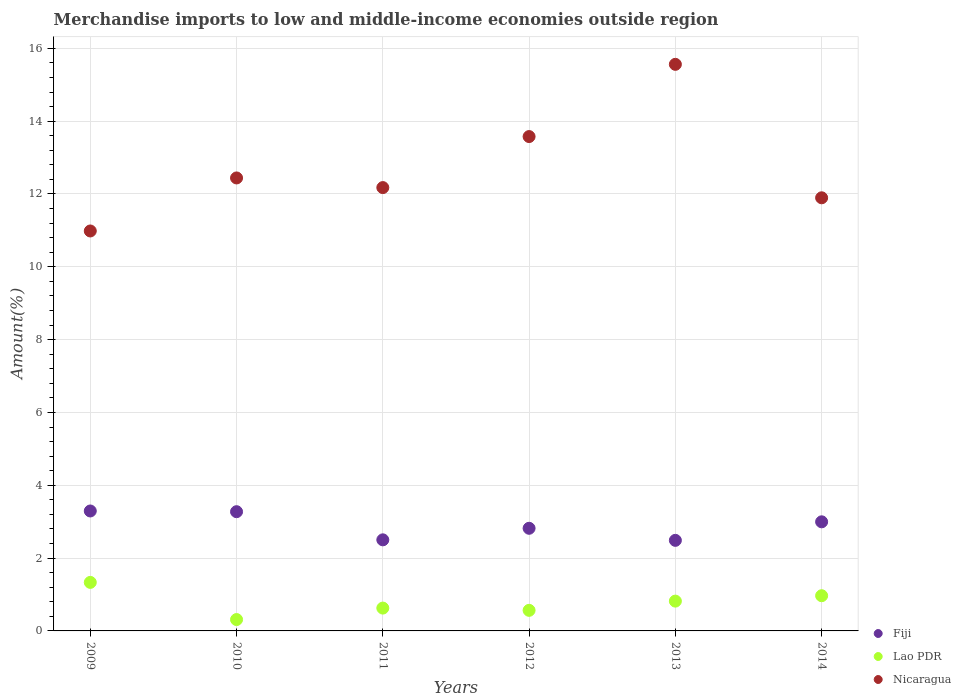How many different coloured dotlines are there?
Ensure brevity in your answer.  3. What is the percentage of amount earned from merchandise imports in Nicaragua in 2012?
Provide a short and direct response. 13.58. Across all years, what is the maximum percentage of amount earned from merchandise imports in Fiji?
Your answer should be very brief. 3.29. Across all years, what is the minimum percentage of amount earned from merchandise imports in Lao PDR?
Provide a succinct answer. 0.31. In which year was the percentage of amount earned from merchandise imports in Lao PDR minimum?
Your answer should be very brief. 2010. What is the total percentage of amount earned from merchandise imports in Lao PDR in the graph?
Provide a short and direct response. 4.62. What is the difference between the percentage of amount earned from merchandise imports in Fiji in 2010 and that in 2011?
Give a very brief answer. 0.77. What is the difference between the percentage of amount earned from merchandise imports in Nicaragua in 2011 and the percentage of amount earned from merchandise imports in Fiji in 2010?
Provide a succinct answer. 8.9. What is the average percentage of amount earned from merchandise imports in Nicaragua per year?
Provide a short and direct response. 12.77. In the year 2009, what is the difference between the percentage of amount earned from merchandise imports in Fiji and percentage of amount earned from merchandise imports in Lao PDR?
Your answer should be very brief. 1.96. In how many years, is the percentage of amount earned from merchandise imports in Lao PDR greater than 13.6 %?
Ensure brevity in your answer.  0. What is the ratio of the percentage of amount earned from merchandise imports in Fiji in 2009 to that in 2011?
Your answer should be very brief. 1.32. Is the percentage of amount earned from merchandise imports in Lao PDR in 2012 less than that in 2013?
Make the answer very short. Yes. What is the difference between the highest and the second highest percentage of amount earned from merchandise imports in Nicaragua?
Your answer should be very brief. 1.98. What is the difference between the highest and the lowest percentage of amount earned from merchandise imports in Lao PDR?
Keep it short and to the point. 1.02. Is it the case that in every year, the sum of the percentage of amount earned from merchandise imports in Nicaragua and percentage of amount earned from merchandise imports in Lao PDR  is greater than the percentage of amount earned from merchandise imports in Fiji?
Your answer should be compact. Yes. Does the percentage of amount earned from merchandise imports in Fiji monotonically increase over the years?
Your answer should be compact. No. Is the percentage of amount earned from merchandise imports in Nicaragua strictly greater than the percentage of amount earned from merchandise imports in Lao PDR over the years?
Provide a short and direct response. Yes. How many dotlines are there?
Provide a succinct answer. 3. How many years are there in the graph?
Keep it short and to the point. 6. What is the difference between two consecutive major ticks on the Y-axis?
Make the answer very short. 2. How are the legend labels stacked?
Provide a succinct answer. Vertical. What is the title of the graph?
Offer a very short reply. Merchandise imports to low and middle-income economies outside region. What is the label or title of the Y-axis?
Make the answer very short. Amount(%). What is the Amount(%) in Fiji in 2009?
Provide a succinct answer. 3.29. What is the Amount(%) of Lao PDR in 2009?
Your answer should be very brief. 1.33. What is the Amount(%) in Nicaragua in 2009?
Give a very brief answer. 10.98. What is the Amount(%) in Fiji in 2010?
Make the answer very short. 3.27. What is the Amount(%) in Lao PDR in 2010?
Provide a short and direct response. 0.31. What is the Amount(%) of Nicaragua in 2010?
Provide a short and direct response. 12.44. What is the Amount(%) in Fiji in 2011?
Make the answer very short. 2.5. What is the Amount(%) of Lao PDR in 2011?
Make the answer very short. 0.63. What is the Amount(%) in Nicaragua in 2011?
Make the answer very short. 12.18. What is the Amount(%) in Fiji in 2012?
Keep it short and to the point. 2.82. What is the Amount(%) in Lao PDR in 2012?
Your answer should be compact. 0.57. What is the Amount(%) in Nicaragua in 2012?
Provide a short and direct response. 13.58. What is the Amount(%) of Fiji in 2013?
Your response must be concise. 2.49. What is the Amount(%) of Lao PDR in 2013?
Your answer should be very brief. 0.82. What is the Amount(%) in Nicaragua in 2013?
Make the answer very short. 15.56. What is the Amount(%) in Fiji in 2014?
Offer a terse response. 3. What is the Amount(%) in Lao PDR in 2014?
Keep it short and to the point. 0.97. What is the Amount(%) of Nicaragua in 2014?
Ensure brevity in your answer.  11.9. Across all years, what is the maximum Amount(%) in Fiji?
Your answer should be very brief. 3.29. Across all years, what is the maximum Amount(%) of Lao PDR?
Ensure brevity in your answer.  1.33. Across all years, what is the maximum Amount(%) in Nicaragua?
Offer a very short reply. 15.56. Across all years, what is the minimum Amount(%) of Fiji?
Provide a succinct answer. 2.49. Across all years, what is the minimum Amount(%) in Lao PDR?
Keep it short and to the point. 0.31. Across all years, what is the minimum Amount(%) of Nicaragua?
Offer a very short reply. 10.98. What is the total Amount(%) of Fiji in the graph?
Provide a short and direct response. 17.37. What is the total Amount(%) in Lao PDR in the graph?
Your response must be concise. 4.62. What is the total Amount(%) in Nicaragua in the graph?
Offer a terse response. 76.64. What is the difference between the Amount(%) in Fiji in 2009 and that in 2010?
Your response must be concise. 0.02. What is the difference between the Amount(%) in Lao PDR in 2009 and that in 2010?
Provide a short and direct response. 1.02. What is the difference between the Amount(%) of Nicaragua in 2009 and that in 2010?
Ensure brevity in your answer.  -1.46. What is the difference between the Amount(%) of Fiji in 2009 and that in 2011?
Give a very brief answer. 0.79. What is the difference between the Amount(%) of Lao PDR in 2009 and that in 2011?
Offer a very short reply. 0.71. What is the difference between the Amount(%) in Nicaragua in 2009 and that in 2011?
Provide a succinct answer. -1.19. What is the difference between the Amount(%) in Fiji in 2009 and that in 2012?
Your response must be concise. 0.48. What is the difference between the Amount(%) of Lao PDR in 2009 and that in 2012?
Provide a short and direct response. 0.77. What is the difference between the Amount(%) of Nicaragua in 2009 and that in 2012?
Give a very brief answer. -2.59. What is the difference between the Amount(%) of Fiji in 2009 and that in 2013?
Make the answer very short. 0.81. What is the difference between the Amount(%) in Lao PDR in 2009 and that in 2013?
Offer a terse response. 0.51. What is the difference between the Amount(%) of Nicaragua in 2009 and that in 2013?
Provide a succinct answer. -4.58. What is the difference between the Amount(%) in Fiji in 2009 and that in 2014?
Provide a succinct answer. 0.3. What is the difference between the Amount(%) of Lao PDR in 2009 and that in 2014?
Keep it short and to the point. 0.37. What is the difference between the Amount(%) in Nicaragua in 2009 and that in 2014?
Your answer should be very brief. -0.91. What is the difference between the Amount(%) of Fiji in 2010 and that in 2011?
Keep it short and to the point. 0.77. What is the difference between the Amount(%) of Lao PDR in 2010 and that in 2011?
Provide a succinct answer. -0.32. What is the difference between the Amount(%) in Nicaragua in 2010 and that in 2011?
Ensure brevity in your answer.  0.26. What is the difference between the Amount(%) of Fiji in 2010 and that in 2012?
Offer a very short reply. 0.46. What is the difference between the Amount(%) of Lao PDR in 2010 and that in 2012?
Offer a terse response. -0.25. What is the difference between the Amount(%) in Nicaragua in 2010 and that in 2012?
Make the answer very short. -1.14. What is the difference between the Amount(%) in Fiji in 2010 and that in 2013?
Offer a very short reply. 0.79. What is the difference between the Amount(%) in Lao PDR in 2010 and that in 2013?
Provide a short and direct response. -0.51. What is the difference between the Amount(%) in Nicaragua in 2010 and that in 2013?
Provide a succinct answer. -3.12. What is the difference between the Amount(%) in Fiji in 2010 and that in 2014?
Provide a succinct answer. 0.28. What is the difference between the Amount(%) in Lao PDR in 2010 and that in 2014?
Offer a very short reply. -0.65. What is the difference between the Amount(%) of Nicaragua in 2010 and that in 2014?
Your response must be concise. 0.55. What is the difference between the Amount(%) of Fiji in 2011 and that in 2012?
Give a very brief answer. -0.32. What is the difference between the Amount(%) in Lao PDR in 2011 and that in 2012?
Your answer should be very brief. 0.06. What is the difference between the Amount(%) in Nicaragua in 2011 and that in 2012?
Ensure brevity in your answer.  -1.4. What is the difference between the Amount(%) of Fiji in 2011 and that in 2013?
Offer a very short reply. 0.01. What is the difference between the Amount(%) of Lao PDR in 2011 and that in 2013?
Keep it short and to the point. -0.19. What is the difference between the Amount(%) of Nicaragua in 2011 and that in 2013?
Offer a very short reply. -3.39. What is the difference between the Amount(%) in Fiji in 2011 and that in 2014?
Provide a short and direct response. -0.49. What is the difference between the Amount(%) of Lao PDR in 2011 and that in 2014?
Provide a short and direct response. -0.34. What is the difference between the Amount(%) of Nicaragua in 2011 and that in 2014?
Your answer should be very brief. 0.28. What is the difference between the Amount(%) in Fiji in 2012 and that in 2013?
Provide a succinct answer. 0.33. What is the difference between the Amount(%) in Lao PDR in 2012 and that in 2013?
Offer a terse response. -0.25. What is the difference between the Amount(%) in Nicaragua in 2012 and that in 2013?
Offer a terse response. -1.98. What is the difference between the Amount(%) of Fiji in 2012 and that in 2014?
Your response must be concise. -0.18. What is the difference between the Amount(%) in Lao PDR in 2012 and that in 2014?
Provide a succinct answer. -0.4. What is the difference between the Amount(%) in Nicaragua in 2012 and that in 2014?
Offer a terse response. 1.68. What is the difference between the Amount(%) of Fiji in 2013 and that in 2014?
Provide a short and direct response. -0.51. What is the difference between the Amount(%) in Lao PDR in 2013 and that in 2014?
Offer a very short reply. -0.15. What is the difference between the Amount(%) in Nicaragua in 2013 and that in 2014?
Offer a very short reply. 3.67. What is the difference between the Amount(%) of Fiji in 2009 and the Amount(%) of Lao PDR in 2010?
Ensure brevity in your answer.  2.98. What is the difference between the Amount(%) of Fiji in 2009 and the Amount(%) of Nicaragua in 2010?
Your answer should be very brief. -9.15. What is the difference between the Amount(%) of Lao PDR in 2009 and the Amount(%) of Nicaragua in 2010?
Ensure brevity in your answer.  -11.11. What is the difference between the Amount(%) in Fiji in 2009 and the Amount(%) in Lao PDR in 2011?
Offer a terse response. 2.67. What is the difference between the Amount(%) of Fiji in 2009 and the Amount(%) of Nicaragua in 2011?
Provide a short and direct response. -8.88. What is the difference between the Amount(%) in Lao PDR in 2009 and the Amount(%) in Nicaragua in 2011?
Keep it short and to the point. -10.84. What is the difference between the Amount(%) of Fiji in 2009 and the Amount(%) of Lao PDR in 2012?
Provide a succinct answer. 2.73. What is the difference between the Amount(%) of Fiji in 2009 and the Amount(%) of Nicaragua in 2012?
Ensure brevity in your answer.  -10.28. What is the difference between the Amount(%) in Lao PDR in 2009 and the Amount(%) in Nicaragua in 2012?
Provide a succinct answer. -12.24. What is the difference between the Amount(%) of Fiji in 2009 and the Amount(%) of Lao PDR in 2013?
Your response must be concise. 2.48. What is the difference between the Amount(%) of Fiji in 2009 and the Amount(%) of Nicaragua in 2013?
Give a very brief answer. -12.27. What is the difference between the Amount(%) in Lao PDR in 2009 and the Amount(%) in Nicaragua in 2013?
Provide a succinct answer. -14.23. What is the difference between the Amount(%) of Fiji in 2009 and the Amount(%) of Lao PDR in 2014?
Ensure brevity in your answer.  2.33. What is the difference between the Amount(%) in Fiji in 2009 and the Amount(%) in Nicaragua in 2014?
Offer a very short reply. -8.6. What is the difference between the Amount(%) in Lao PDR in 2009 and the Amount(%) in Nicaragua in 2014?
Offer a very short reply. -10.56. What is the difference between the Amount(%) in Fiji in 2010 and the Amount(%) in Lao PDR in 2011?
Your answer should be compact. 2.65. What is the difference between the Amount(%) in Fiji in 2010 and the Amount(%) in Nicaragua in 2011?
Offer a very short reply. -8.9. What is the difference between the Amount(%) in Lao PDR in 2010 and the Amount(%) in Nicaragua in 2011?
Your answer should be compact. -11.86. What is the difference between the Amount(%) in Fiji in 2010 and the Amount(%) in Lao PDR in 2012?
Your response must be concise. 2.71. What is the difference between the Amount(%) of Fiji in 2010 and the Amount(%) of Nicaragua in 2012?
Provide a short and direct response. -10.3. What is the difference between the Amount(%) of Lao PDR in 2010 and the Amount(%) of Nicaragua in 2012?
Your answer should be compact. -13.27. What is the difference between the Amount(%) in Fiji in 2010 and the Amount(%) in Lao PDR in 2013?
Keep it short and to the point. 2.46. What is the difference between the Amount(%) in Fiji in 2010 and the Amount(%) in Nicaragua in 2013?
Give a very brief answer. -12.29. What is the difference between the Amount(%) of Lao PDR in 2010 and the Amount(%) of Nicaragua in 2013?
Your answer should be compact. -15.25. What is the difference between the Amount(%) in Fiji in 2010 and the Amount(%) in Lao PDR in 2014?
Offer a very short reply. 2.31. What is the difference between the Amount(%) of Fiji in 2010 and the Amount(%) of Nicaragua in 2014?
Provide a short and direct response. -8.62. What is the difference between the Amount(%) in Lao PDR in 2010 and the Amount(%) in Nicaragua in 2014?
Offer a terse response. -11.58. What is the difference between the Amount(%) in Fiji in 2011 and the Amount(%) in Lao PDR in 2012?
Make the answer very short. 1.94. What is the difference between the Amount(%) in Fiji in 2011 and the Amount(%) in Nicaragua in 2012?
Provide a succinct answer. -11.08. What is the difference between the Amount(%) in Lao PDR in 2011 and the Amount(%) in Nicaragua in 2012?
Offer a very short reply. -12.95. What is the difference between the Amount(%) of Fiji in 2011 and the Amount(%) of Lao PDR in 2013?
Your response must be concise. 1.68. What is the difference between the Amount(%) of Fiji in 2011 and the Amount(%) of Nicaragua in 2013?
Your answer should be very brief. -13.06. What is the difference between the Amount(%) in Lao PDR in 2011 and the Amount(%) in Nicaragua in 2013?
Keep it short and to the point. -14.93. What is the difference between the Amount(%) of Fiji in 2011 and the Amount(%) of Lao PDR in 2014?
Offer a very short reply. 1.53. What is the difference between the Amount(%) in Fiji in 2011 and the Amount(%) in Nicaragua in 2014?
Provide a short and direct response. -9.39. What is the difference between the Amount(%) in Lao PDR in 2011 and the Amount(%) in Nicaragua in 2014?
Your answer should be very brief. -11.27. What is the difference between the Amount(%) of Fiji in 2012 and the Amount(%) of Lao PDR in 2013?
Offer a terse response. 2. What is the difference between the Amount(%) of Fiji in 2012 and the Amount(%) of Nicaragua in 2013?
Provide a short and direct response. -12.74. What is the difference between the Amount(%) in Lao PDR in 2012 and the Amount(%) in Nicaragua in 2013?
Offer a very short reply. -15. What is the difference between the Amount(%) of Fiji in 2012 and the Amount(%) of Lao PDR in 2014?
Your answer should be compact. 1.85. What is the difference between the Amount(%) in Fiji in 2012 and the Amount(%) in Nicaragua in 2014?
Your answer should be very brief. -9.08. What is the difference between the Amount(%) of Lao PDR in 2012 and the Amount(%) of Nicaragua in 2014?
Offer a very short reply. -11.33. What is the difference between the Amount(%) of Fiji in 2013 and the Amount(%) of Lao PDR in 2014?
Provide a succinct answer. 1.52. What is the difference between the Amount(%) of Fiji in 2013 and the Amount(%) of Nicaragua in 2014?
Your response must be concise. -9.41. What is the difference between the Amount(%) in Lao PDR in 2013 and the Amount(%) in Nicaragua in 2014?
Your answer should be very brief. -11.08. What is the average Amount(%) in Fiji per year?
Provide a short and direct response. 2.9. What is the average Amount(%) of Lao PDR per year?
Provide a short and direct response. 0.77. What is the average Amount(%) of Nicaragua per year?
Ensure brevity in your answer.  12.77. In the year 2009, what is the difference between the Amount(%) of Fiji and Amount(%) of Lao PDR?
Offer a terse response. 1.96. In the year 2009, what is the difference between the Amount(%) in Fiji and Amount(%) in Nicaragua?
Keep it short and to the point. -7.69. In the year 2009, what is the difference between the Amount(%) of Lao PDR and Amount(%) of Nicaragua?
Your answer should be very brief. -9.65. In the year 2010, what is the difference between the Amount(%) in Fiji and Amount(%) in Lao PDR?
Give a very brief answer. 2.96. In the year 2010, what is the difference between the Amount(%) in Fiji and Amount(%) in Nicaragua?
Offer a terse response. -9.17. In the year 2010, what is the difference between the Amount(%) of Lao PDR and Amount(%) of Nicaragua?
Provide a succinct answer. -12.13. In the year 2011, what is the difference between the Amount(%) of Fiji and Amount(%) of Lao PDR?
Ensure brevity in your answer.  1.87. In the year 2011, what is the difference between the Amount(%) in Fiji and Amount(%) in Nicaragua?
Make the answer very short. -9.67. In the year 2011, what is the difference between the Amount(%) in Lao PDR and Amount(%) in Nicaragua?
Offer a very short reply. -11.55. In the year 2012, what is the difference between the Amount(%) of Fiji and Amount(%) of Lao PDR?
Offer a terse response. 2.25. In the year 2012, what is the difference between the Amount(%) in Fiji and Amount(%) in Nicaragua?
Provide a succinct answer. -10.76. In the year 2012, what is the difference between the Amount(%) of Lao PDR and Amount(%) of Nicaragua?
Give a very brief answer. -13.01. In the year 2013, what is the difference between the Amount(%) of Fiji and Amount(%) of Lao PDR?
Provide a succinct answer. 1.67. In the year 2013, what is the difference between the Amount(%) in Fiji and Amount(%) in Nicaragua?
Ensure brevity in your answer.  -13.07. In the year 2013, what is the difference between the Amount(%) in Lao PDR and Amount(%) in Nicaragua?
Provide a short and direct response. -14.74. In the year 2014, what is the difference between the Amount(%) in Fiji and Amount(%) in Lao PDR?
Offer a very short reply. 2.03. In the year 2014, what is the difference between the Amount(%) in Fiji and Amount(%) in Nicaragua?
Offer a terse response. -8.9. In the year 2014, what is the difference between the Amount(%) in Lao PDR and Amount(%) in Nicaragua?
Ensure brevity in your answer.  -10.93. What is the ratio of the Amount(%) of Fiji in 2009 to that in 2010?
Give a very brief answer. 1.01. What is the ratio of the Amount(%) of Lao PDR in 2009 to that in 2010?
Keep it short and to the point. 4.27. What is the ratio of the Amount(%) of Nicaragua in 2009 to that in 2010?
Your answer should be very brief. 0.88. What is the ratio of the Amount(%) in Fiji in 2009 to that in 2011?
Keep it short and to the point. 1.32. What is the ratio of the Amount(%) in Lao PDR in 2009 to that in 2011?
Provide a short and direct response. 2.12. What is the ratio of the Amount(%) in Nicaragua in 2009 to that in 2011?
Provide a short and direct response. 0.9. What is the ratio of the Amount(%) of Fiji in 2009 to that in 2012?
Your answer should be very brief. 1.17. What is the ratio of the Amount(%) of Lao PDR in 2009 to that in 2012?
Ensure brevity in your answer.  2.36. What is the ratio of the Amount(%) in Nicaragua in 2009 to that in 2012?
Your answer should be very brief. 0.81. What is the ratio of the Amount(%) in Fiji in 2009 to that in 2013?
Give a very brief answer. 1.32. What is the ratio of the Amount(%) in Lao PDR in 2009 to that in 2013?
Your answer should be compact. 1.63. What is the ratio of the Amount(%) in Nicaragua in 2009 to that in 2013?
Provide a succinct answer. 0.71. What is the ratio of the Amount(%) in Fiji in 2009 to that in 2014?
Give a very brief answer. 1.1. What is the ratio of the Amount(%) in Lao PDR in 2009 to that in 2014?
Offer a very short reply. 1.38. What is the ratio of the Amount(%) of Nicaragua in 2009 to that in 2014?
Provide a succinct answer. 0.92. What is the ratio of the Amount(%) in Fiji in 2010 to that in 2011?
Ensure brevity in your answer.  1.31. What is the ratio of the Amount(%) in Lao PDR in 2010 to that in 2011?
Your answer should be compact. 0.5. What is the ratio of the Amount(%) in Nicaragua in 2010 to that in 2011?
Keep it short and to the point. 1.02. What is the ratio of the Amount(%) in Fiji in 2010 to that in 2012?
Ensure brevity in your answer.  1.16. What is the ratio of the Amount(%) of Lao PDR in 2010 to that in 2012?
Your response must be concise. 0.55. What is the ratio of the Amount(%) in Nicaragua in 2010 to that in 2012?
Offer a very short reply. 0.92. What is the ratio of the Amount(%) of Fiji in 2010 to that in 2013?
Give a very brief answer. 1.32. What is the ratio of the Amount(%) of Lao PDR in 2010 to that in 2013?
Provide a short and direct response. 0.38. What is the ratio of the Amount(%) of Nicaragua in 2010 to that in 2013?
Provide a succinct answer. 0.8. What is the ratio of the Amount(%) in Fiji in 2010 to that in 2014?
Provide a short and direct response. 1.09. What is the ratio of the Amount(%) of Lao PDR in 2010 to that in 2014?
Offer a terse response. 0.32. What is the ratio of the Amount(%) of Nicaragua in 2010 to that in 2014?
Provide a short and direct response. 1.05. What is the ratio of the Amount(%) of Fiji in 2011 to that in 2012?
Keep it short and to the point. 0.89. What is the ratio of the Amount(%) in Lao PDR in 2011 to that in 2012?
Make the answer very short. 1.11. What is the ratio of the Amount(%) of Nicaragua in 2011 to that in 2012?
Your response must be concise. 0.9. What is the ratio of the Amount(%) in Fiji in 2011 to that in 2013?
Ensure brevity in your answer.  1.01. What is the ratio of the Amount(%) in Lao PDR in 2011 to that in 2013?
Your response must be concise. 0.77. What is the ratio of the Amount(%) in Nicaragua in 2011 to that in 2013?
Ensure brevity in your answer.  0.78. What is the ratio of the Amount(%) in Fiji in 2011 to that in 2014?
Offer a terse response. 0.83. What is the ratio of the Amount(%) of Lao PDR in 2011 to that in 2014?
Ensure brevity in your answer.  0.65. What is the ratio of the Amount(%) in Nicaragua in 2011 to that in 2014?
Keep it short and to the point. 1.02. What is the ratio of the Amount(%) in Fiji in 2012 to that in 2013?
Offer a very short reply. 1.13. What is the ratio of the Amount(%) in Lao PDR in 2012 to that in 2013?
Your response must be concise. 0.69. What is the ratio of the Amount(%) in Nicaragua in 2012 to that in 2013?
Ensure brevity in your answer.  0.87. What is the ratio of the Amount(%) in Fiji in 2012 to that in 2014?
Make the answer very short. 0.94. What is the ratio of the Amount(%) of Lao PDR in 2012 to that in 2014?
Ensure brevity in your answer.  0.58. What is the ratio of the Amount(%) of Nicaragua in 2012 to that in 2014?
Provide a short and direct response. 1.14. What is the ratio of the Amount(%) of Fiji in 2013 to that in 2014?
Offer a very short reply. 0.83. What is the ratio of the Amount(%) of Lao PDR in 2013 to that in 2014?
Keep it short and to the point. 0.85. What is the ratio of the Amount(%) in Nicaragua in 2013 to that in 2014?
Give a very brief answer. 1.31. What is the difference between the highest and the second highest Amount(%) of Fiji?
Ensure brevity in your answer.  0.02. What is the difference between the highest and the second highest Amount(%) in Lao PDR?
Your answer should be very brief. 0.37. What is the difference between the highest and the second highest Amount(%) in Nicaragua?
Your response must be concise. 1.98. What is the difference between the highest and the lowest Amount(%) of Fiji?
Provide a succinct answer. 0.81. What is the difference between the highest and the lowest Amount(%) of Lao PDR?
Give a very brief answer. 1.02. What is the difference between the highest and the lowest Amount(%) of Nicaragua?
Your response must be concise. 4.58. 